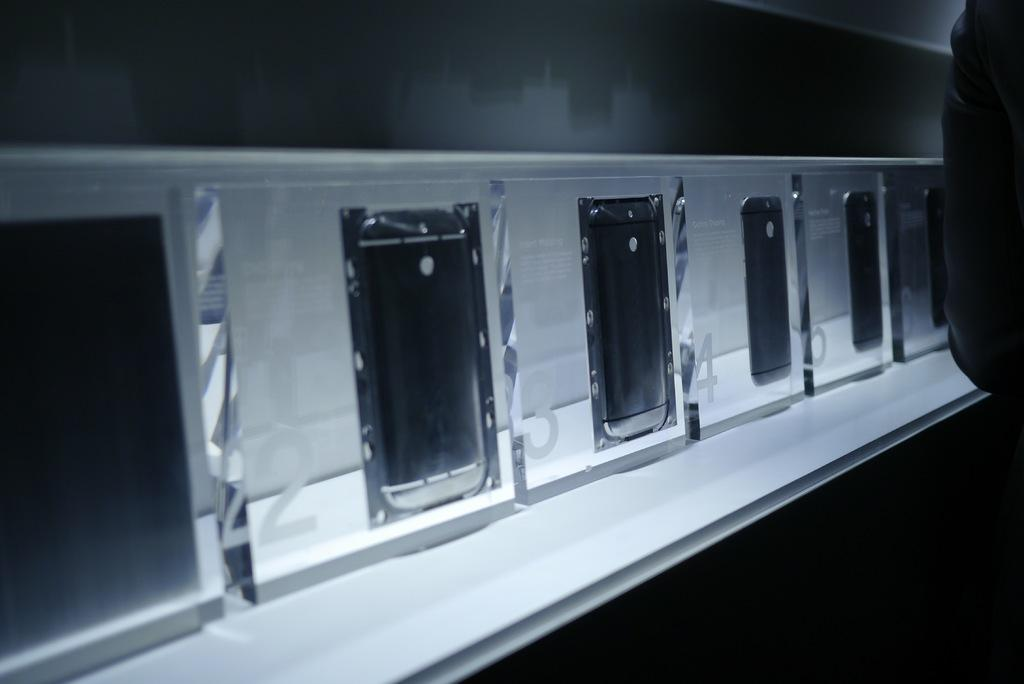<image>
Give a short and clear explanation of the subsequent image. Many phones labeled 1-6 are behind glass displays. 